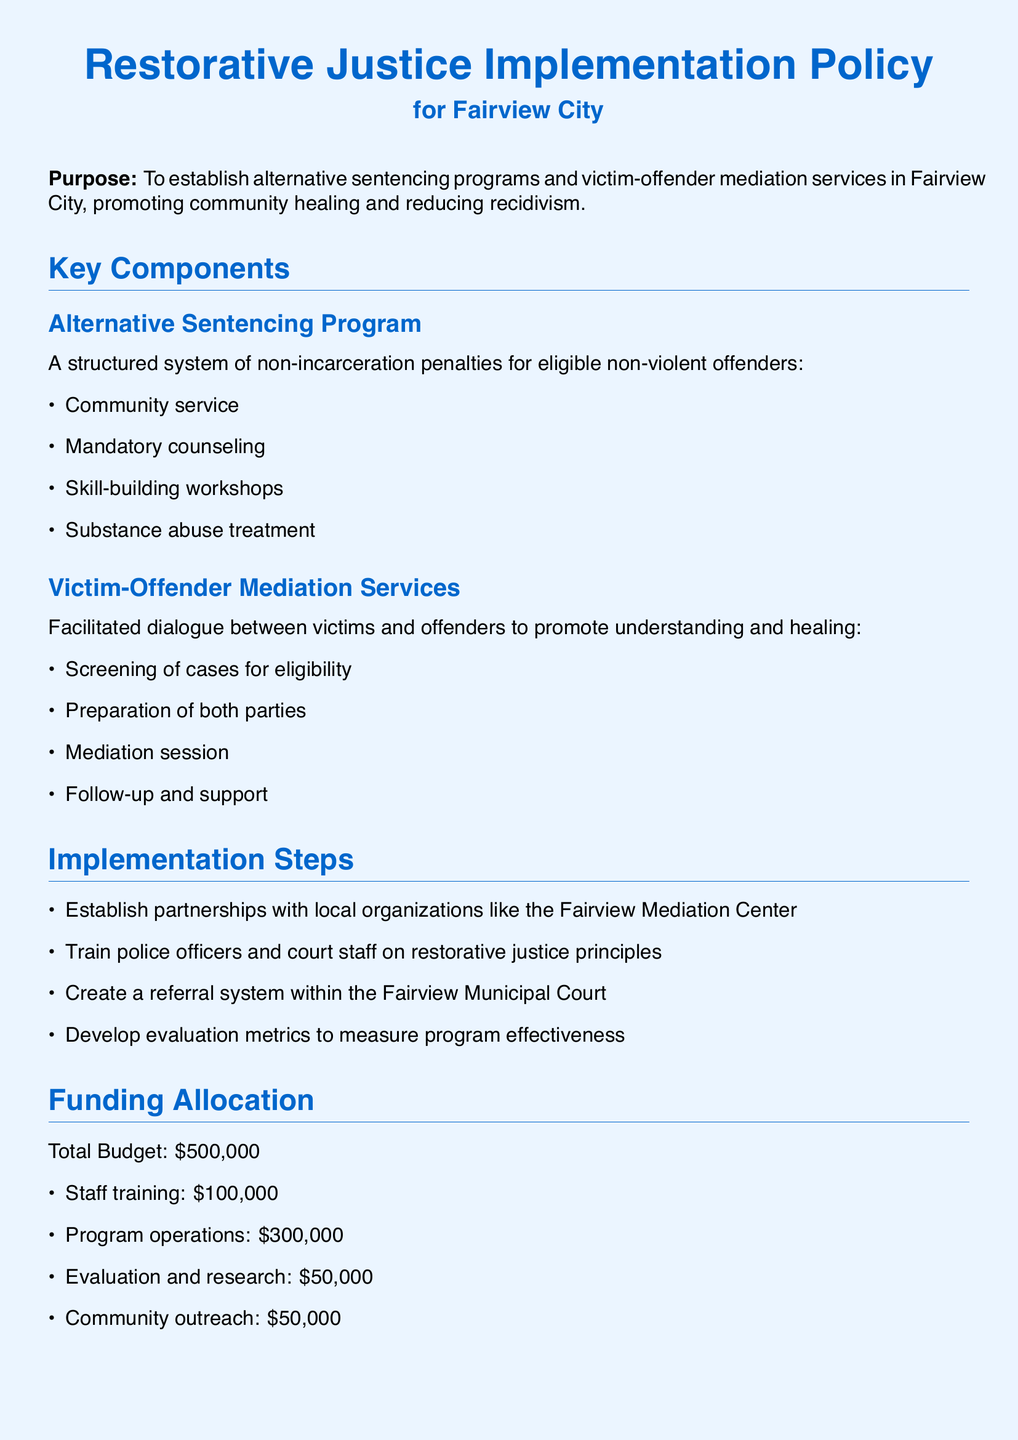What is the total budget for the Restorative Justice Implementation Policy? The total budget is specified in the document, outlining the total allocation for the program.
Answer: $500,000 What is the first step of the implementation process? The implementation steps list the actions to begin the program, starting with establishing partnerships.
Answer: Establish partnerships with local organizations What percentage reduction in recidivism rates is expected within three years? The expected outcomes mention specific targets, including the reduction in recidivism.
Answer: 20% What types of services are included in the Victim-Offender Mediation Services? The document outlines the main components of the mediation services as listed under that section.
Answer: Facilitated dialogue How much funding is allocated for staff training? The funding allocation section specifies how the budget is divided among different areas, including staff training.
Answer: $100,000 What organization is mentioned for partnership in the implementation steps? The document references a specific local organization to form partnerships with during implementation.
Answer: Fairview Mediation Center What is one expected outcome related to victim satisfaction? One of the expected outcomes specifically addresses the views of victims regarding the justice process.
Answer: Increased victim satisfaction How much budget is dedicated to evaluation and research? The funding allocation section provides details on the specific budget for evaluation and research.
Answer: $50,000 